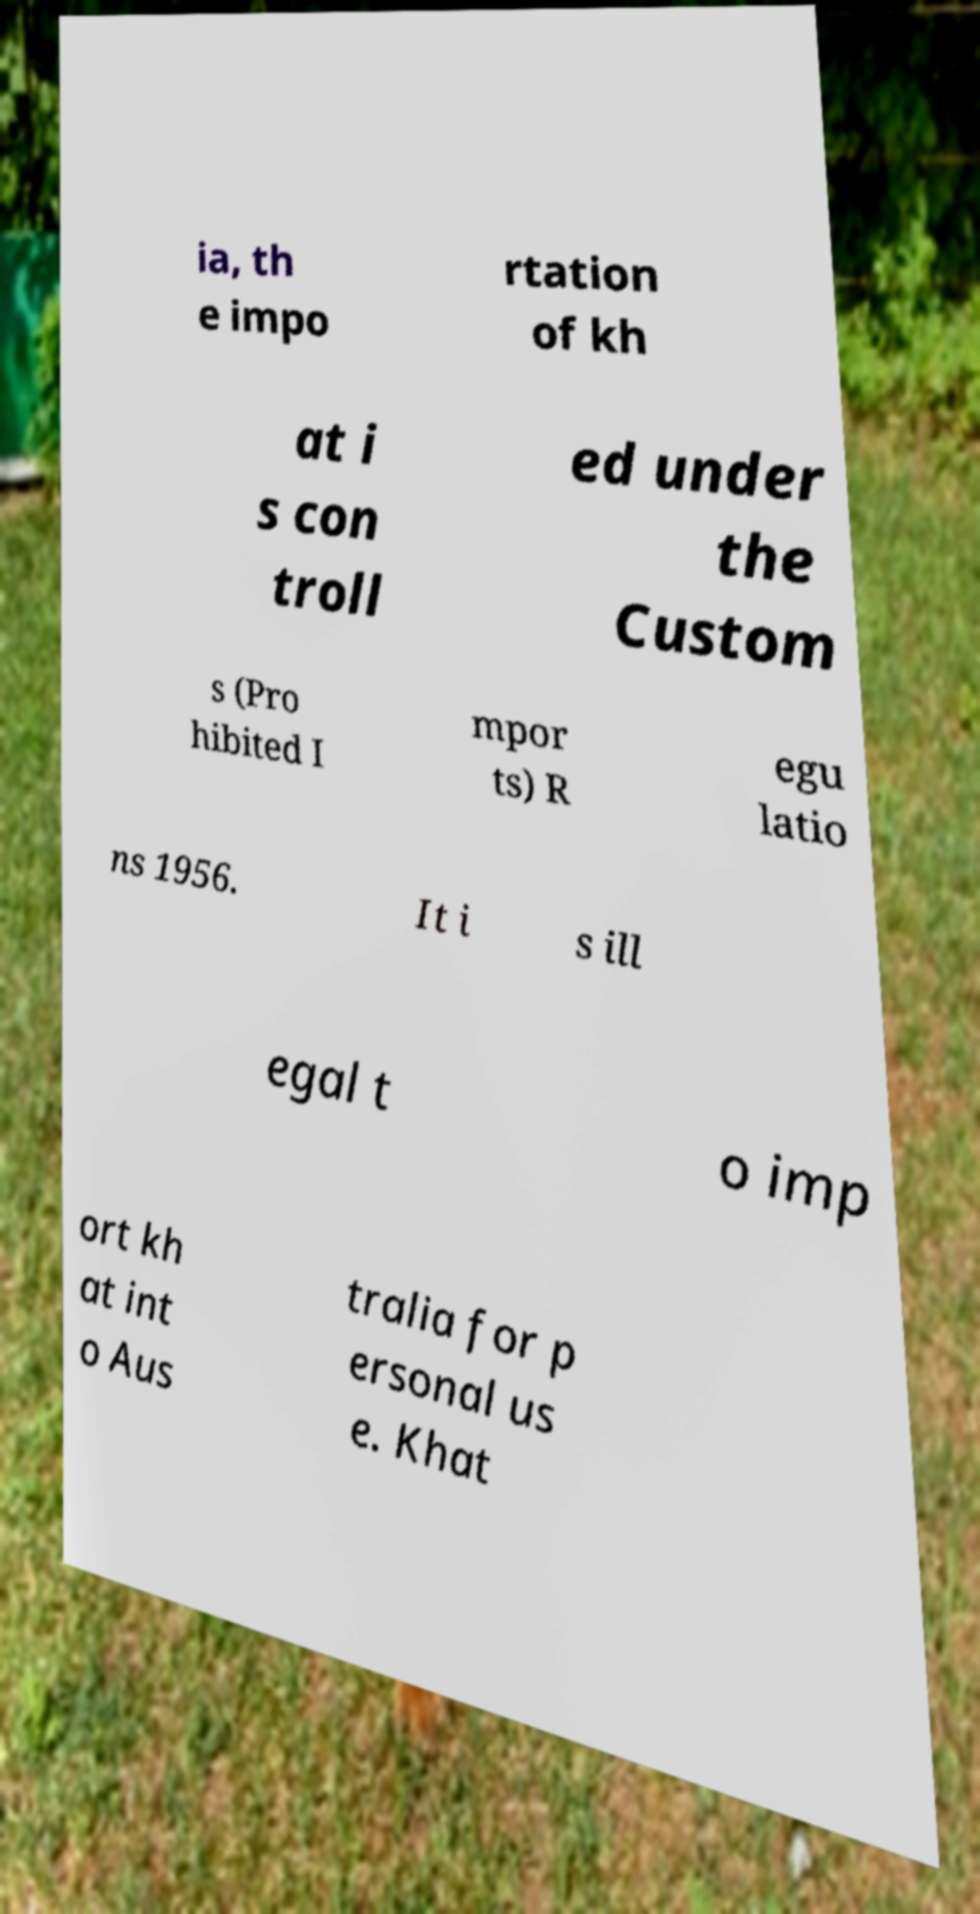Please identify and transcribe the text found in this image. ia, th e impo rtation of kh at i s con troll ed under the Custom s (Pro hibited I mpor ts) R egu latio ns 1956. It i s ill egal t o imp ort kh at int o Aus tralia for p ersonal us e. Khat 